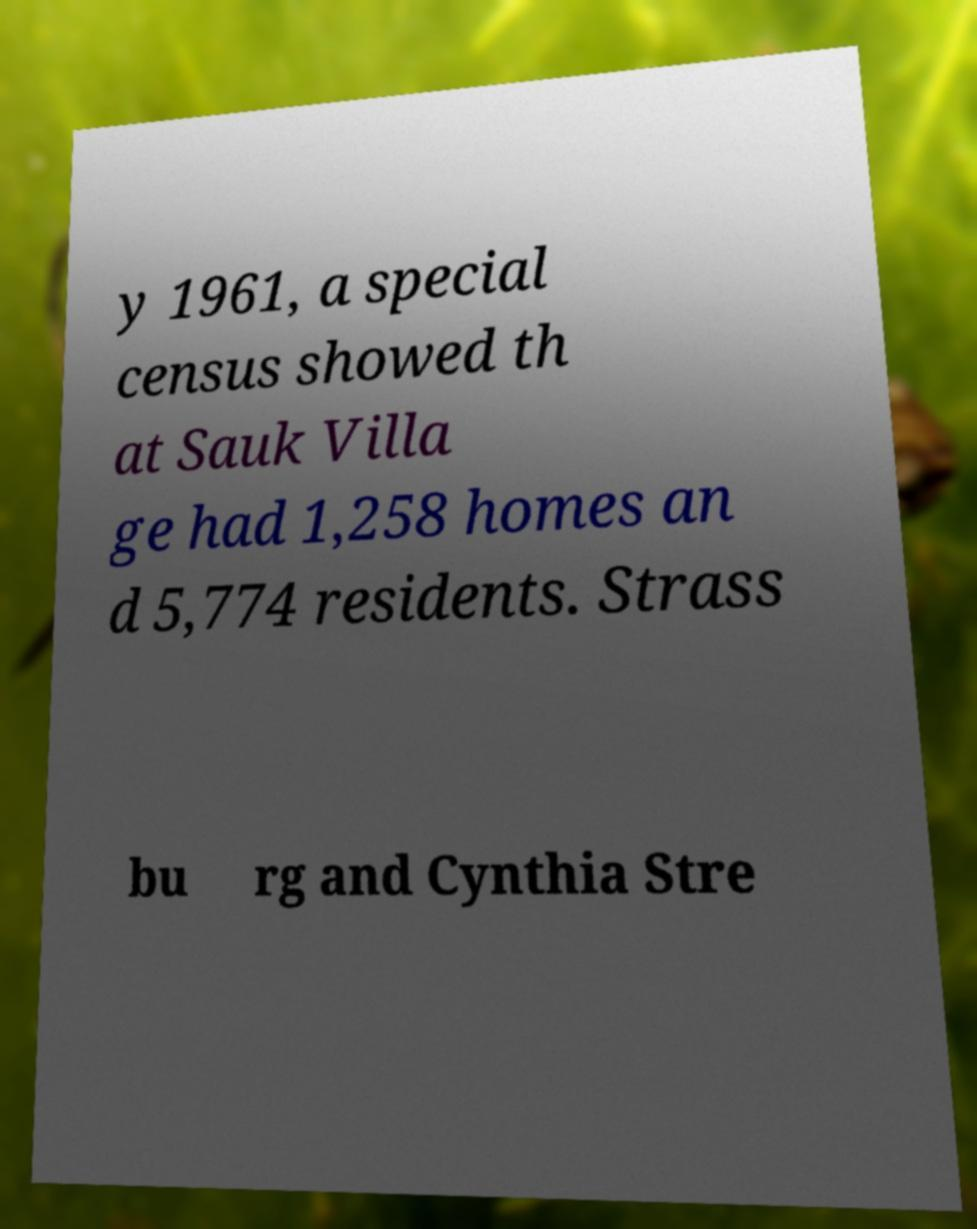Can you read and provide the text displayed in the image?This photo seems to have some interesting text. Can you extract and type it out for me? y 1961, a special census showed th at Sauk Villa ge had 1,258 homes an d 5,774 residents. Strass bu rg and Cynthia Stre 